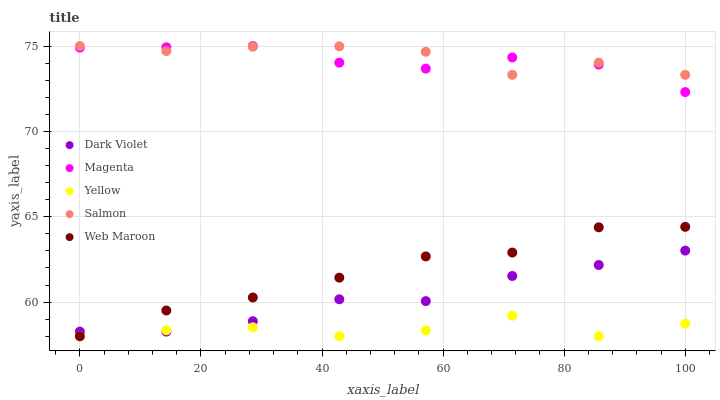Does Yellow have the minimum area under the curve?
Answer yes or no. Yes. Does Salmon have the maximum area under the curve?
Answer yes or no. Yes. Does Magenta have the minimum area under the curve?
Answer yes or no. No. Does Magenta have the maximum area under the curve?
Answer yes or no. No. Is Web Maroon the smoothest?
Answer yes or no. Yes. Is Yellow the roughest?
Answer yes or no. Yes. Is Magenta the smoothest?
Answer yes or no. No. Is Magenta the roughest?
Answer yes or no. No. Does Web Maroon have the lowest value?
Answer yes or no. Yes. Does Magenta have the lowest value?
Answer yes or no. No. Does Salmon have the highest value?
Answer yes or no. Yes. Does Yellow have the highest value?
Answer yes or no. No. Is Yellow less than Magenta?
Answer yes or no. Yes. Is Salmon greater than Yellow?
Answer yes or no. Yes. Does Yellow intersect Web Maroon?
Answer yes or no. Yes. Is Yellow less than Web Maroon?
Answer yes or no. No. Is Yellow greater than Web Maroon?
Answer yes or no. No. Does Yellow intersect Magenta?
Answer yes or no. No. 